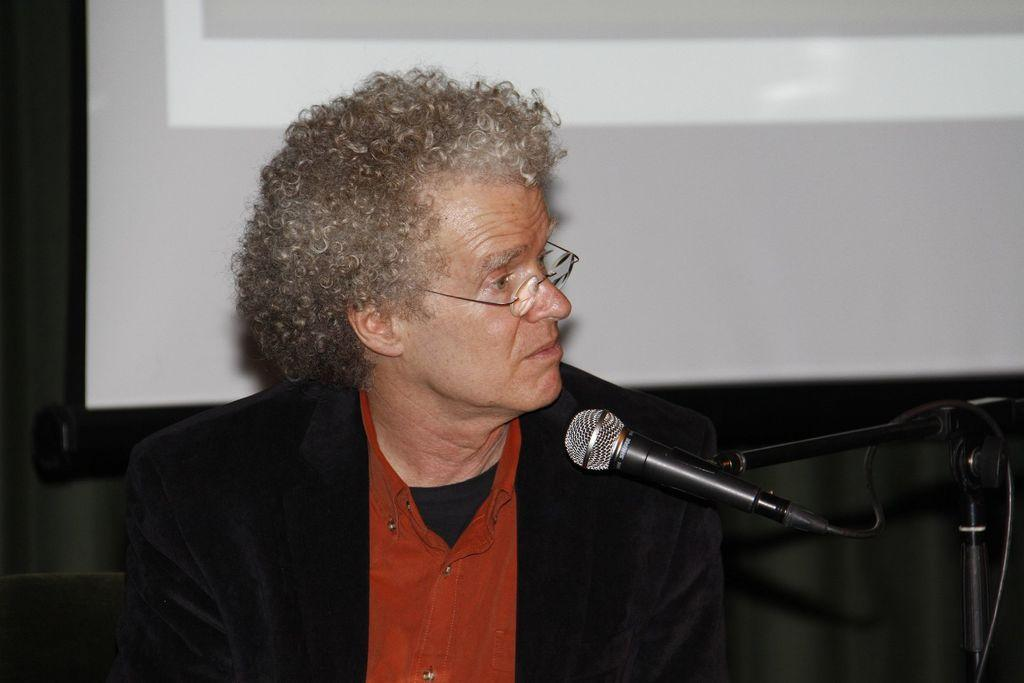What is the main subject of the image? There is a person sitting in the center of the image. What is the person holding in the image? The person is holding a microphone (mike). What can be seen in the background of the image? There is a screen in the background of the image. How many rabbits are visible on the screen in the image? There are no rabbits visible on the screen in the image. What color are the person's eyes in the image? The provided facts do not mention the person's eyes, so we cannot determine their color from the image. 